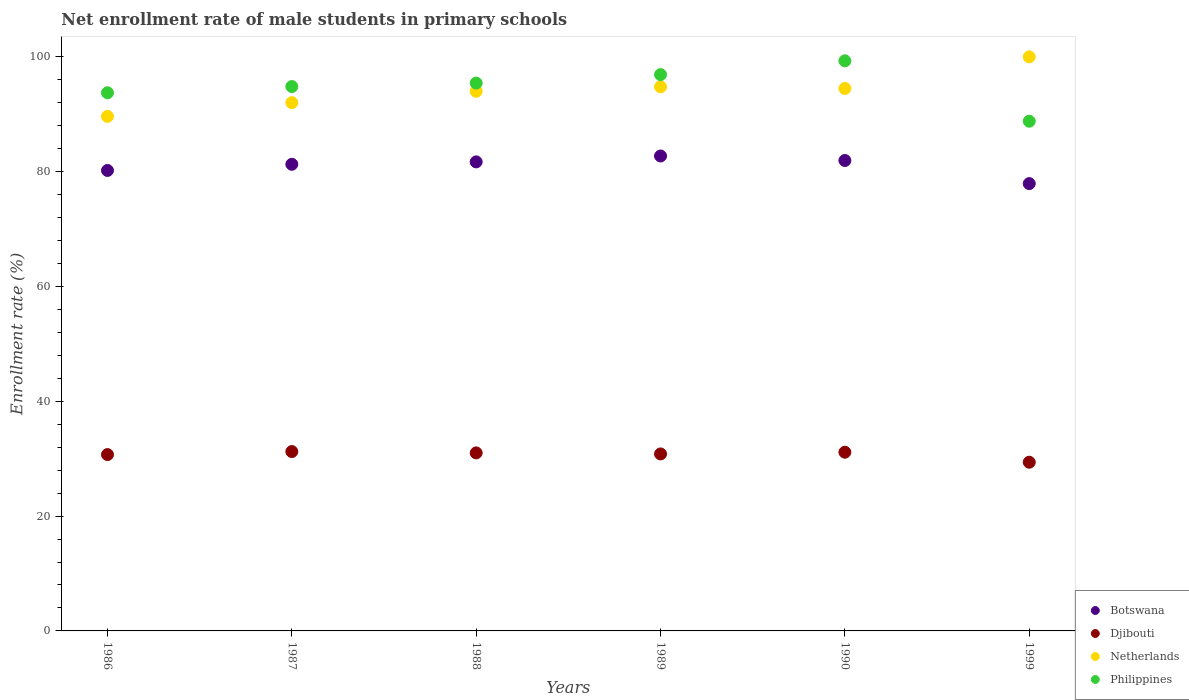What is the net enrollment rate of male students in primary schools in Djibouti in 1986?
Keep it short and to the point. 30.71. Across all years, what is the maximum net enrollment rate of male students in primary schools in Djibouti?
Offer a very short reply. 31.24. Across all years, what is the minimum net enrollment rate of male students in primary schools in Djibouti?
Your answer should be compact. 29.38. What is the total net enrollment rate of male students in primary schools in Philippines in the graph?
Ensure brevity in your answer.  568.92. What is the difference between the net enrollment rate of male students in primary schools in Netherlands in 1986 and that in 1988?
Provide a succinct answer. -4.37. What is the difference between the net enrollment rate of male students in primary schools in Djibouti in 1989 and the net enrollment rate of male students in primary schools in Netherlands in 1986?
Provide a short and direct response. -58.79. What is the average net enrollment rate of male students in primary schools in Netherlands per year?
Give a very brief answer. 94.14. In the year 1986, what is the difference between the net enrollment rate of male students in primary schools in Philippines and net enrollment rate of male students in primary schools in Botswana?
Offer a terse response. 13.53. What is the ratio of the net enrollment rate of male students in primary schools in Philippines in 1986 to that in 1989?
Give a very brief answer. 0.97. Is the difference between the net enrollment rate of male students in primary schools in Philippines in 1988 and 1989 greater than the difference between the net enrollment rate of male students in primary schools in Botswana in 1988 and 1989?
Provide a succinct answer. No. What is the difference between the highest and the second highest net enrollment rate of male students in primary schools in Botswana?
Make the answer very short. 0.79. What is the difference between the highest and the lowest net enrollment rate of male students in primary schools in Djibouti?
Your response must be concise. 1.86. Is the sum of the net enrollment rate of male students in primary schools in Djibouti in 1988 and 1989 greater than the maximum net enrollment rate of male students in primary schools in Botswana across all years?
Ensure brevity in your answer.  No. Is it the case that in every year, the sum of the net enrollment rate of male students in primary schools in Philippines and net enrollment rate of male students in primary schools in Botswana  is greater than the sum of net enrollment rate of male students in primary schools in Netherlands and net enrollment rate of male students in primary schools in Djibouti?
Make the answer very short. Yes. Is the net enrollment rate of male students in primary schools in Djibouti strictly greater than the net enrollment rate of male students in primary schools in Netherlands over the years?
Offer a very short reply. No. How many dotlines are there?
Keep it short and to the point. 4. Are the values on the major ticks of Y-axis written in scientific E-notation?
Provide a succinct answer. No. What is the title of the graph?
Give a very brief answer. Net enrollment rate of male students in primary schools. Does "Guam" appear as one of the legend labels in the graph?
Offer a very short reply. No. What is the label or title of the Y-axis?
Keep it short and to the point. Enrollment rate (%). What is the Enrollment rate (%) of Botswana in 1986?
Your response must be concise. 80.2. What is the Enrollment rate (%) of Djibouti in 1986?
Keep it short and to the point. 30.71. What is the Enrollment rate (%) in Netherlands in 1986?
Offer a terse response. 89.61. What is the Enrollment rate (%) in Philippines in 1986?
Your answer should be very brief. 93.73. What is the Enrollment rate (%) in Botswana in 1987?
Your answer should be very brief. 81.27. What is the Enrollment rate (%) of Djibouti in 1987?
Make the answer very short. 31.24. What is the Enrollment rate (%) in Netherlands in 1987?
Give a very brief answer. 92. What is the Enrollment rate (%) of Philippines in 1987?
Provide a short and direct response. 94.81. What is the Enrollment rate (%) in Botswana in 1988?
Offer a very short reply. 81.69. What is the Enrollment rate (%) of Djibouti in 1988?
Offer a very short reply. 31.01. What is the Enrollment rate (%) in Netherlands in 1988?
Your answer should be compact. 93.98. What is the Enrollment rate (%) of Philippines in 1988?
Make the answer very short. 95.42. What is the Enrollment rate (%) in Botswana in 1989?
Offer a very short reply. 82.72. What is the Enrollment rate (%) of Djibouti in 1989?
Make the answer very short. 30.83. What is the Enrollment rate (%) in Netherlands in 1989?
Your response must be concise. 94.76. What is the Enrollment rate (%) in Philippines in 1989?
Offer a very short reply. 96.89. What is the Enrollment rate (%) in Botswana in 1990?
Your answer should be compact. 81.93. What is the Enrollment rate (%) of Djibouti in 1990?
Provide a succinct answer. 31.12. What is the Enrollment rate (%) of Netherlands in 1990?
Your response must be concise. 94.48. What is the Enrollment rate (%) of Philippines in 1990?
Give a very brief answer. 99.29. What is the Enrollment rate (%) of Botswana in 1999?
Keep it short and to the point. 77.91. What is the Enrollment rate (%) in Djibouti in 1999?
Offer a terse response. 29.38. What is the Enrollment rate (%) of Netherlands in 1999?
Give a very brief answer. 99.99. What is the Enrollment rate (%) in Philippines in 1999?
Offer a terse response. 88.77. Across all years, what is the maximum Enrollment rate (%) of Botswana?
Provide a succinct answer. 82.72. Across all years, what is the maximum Enrollment rate (%) of Djibouti?
Your answer should be compact. 31.24. Across all years, what is the maximum Enrollment rate (%) of Netherlands?
Provide a short and direct response. 99.99. Across all years, what is the maximum Enrollment rate (%) in Philippines?
Keep it short and to the point. 99.29. Across all years, what is the minimum Enrollment rate (%) in Botswana?
Your answer should be very brief. 77.91. Across all years, what is the minimum Enrollment rate (%) in Djibouti?
Keep it short and to the point. 29.38. Across all years, what is the minimum Enrollment rate (%) of Netherlands?
Your response must be concise. 89.61. Across all years, what is the minimum Enrollment rate (%) in Philippines?
Make the answer very short. 88.77. What is the total Enrollment rate (%) in Botswana in the graph?
Keep it short and to the point. 485.72. What is the total Enrollment rate (%) of Djibouti in the graph?
Your answer should be very brief. 184.29. What is the total Enrollment rate (%) in Netherlands in the graph?
Ensure brevity in your answer.  564.83. What is the total Enrollment rate (%) of Philippines in the graph?
Your answer should be compact. 568.92. What is the difference between the Enrollment rate (%) of Botswana in 1986 and that in 1987?
Give a very brief answer. -1.08. What is the difference between the Enrollment rate (%) of Djibouti in 1986 and that in 1987?
Your response must be concise. -0.53. What is the difference between the Enrollment rate (%) in Netherlands in 1986 and that in 1987?
Offer a very short reply. -2.39. What is the difference between the Enrollment rate (%) of Philippines in 1986 and that in 1987?
Provide a short and direct response. -1.08. What is the difference between the Enrollment rate (%) of Botswana in 1986 and that in 1988?
Provide a short and direct response. -1.49. What is the difference between the Enrollment rate (%) of Djibouti in 1986 and that in 1988?
Provide a succinct answer. -0.29. What is the difference between the Enrollment rate (%) of Netherlands in 1986 and that in 1988?
Offer a terse response. -4.37. What is the difference between the Enrollment rate (%) of Philippines in 1986 and that in 1988?
Provide a short and direct response. -1.69. What is the difference between the Enrollment rate (%) of Botswana in 1986 and that in 1989?
Ensure brevity in your answer.  -2.52. What is the difference between the Enrollment rate (%) in Djibouti in 1986 and that in 1989?
Give a very brief answer. -0.11. What is the difference between the Enrollment rate (%) of Netherlands in 1986 and that in 1989?
Make the answer very short. -5.15. What is the difference between the Enrollment rate (%) in Philippines in 1986 and that in 1989?
Make the answer very short. -3.16. What is the difference between the Enrollment rate (%) in Botswana in 1986 and that in 1990?
Provide a short and direct response. -1.73. What is the difference between the Enrollment rate (%) in Djibouti in 1986 and that in 1990?
Keep it short and to the point. -0.41. What is the difference between the Enrollment rate (%) in Netherlands in 1986 and that in 1990?
Keep it short and to the point. -4.87. What is the difference between the Enrollment rate (%) in Philippines in 1986 and that in 1990?
Your answer should be compact. -5.56. What is the difference between the Enrollment rate (%) of Botswana in 1986 and that in 1999?
Offer a terse response. 2.29. What is the difference between the Enrollment rate (%) of Djibouti in 1986 and that in 1999?
Offer a terse response. 1.33. What is the difference between the Enrollment rate (%) in Netherlands in 1986 and that in 1999?
Give a very brief answer. -10.37. What is the difference between the Enrollment rate (%) of Philippines in 1986 and that in 1999?
Make the answer very short. 4.96. What is the difference between the Enrollment rate (%) of Botswana in 1987 and that in 1988?
Ensure brevity in your answer.  -0.42. What is the difference between the Enrollment rate (%) of Djibouti in 1987 and that in 1988?
Your answer should be compact. 0.23. What is the difference between the Enrollment rate (%) in Netherlands in 1987 and that in 1988?
Give a very brief answer. -1.98. What is the difference between the Enrollment rate (%) in Philippines in 1987 and that in 1988?
Keep it short and to the point. -0.6. What is the difference between the Enrollment rate (%) in Botswana in 1987 and that in 1989?
Offer a very short reply. -1.44. What is the difference between the Enrollment rate (%) of Djibouti in 1987 and that in 1989?
Provide a short and direct response. 0.41. What is the difference between the Enrollment rate (%) in Netherlands in 1987 and that in 1989?
Give a very brief answer. -2.76. What is the difference between the Enrollment rate (%) in Philippines in 1987 and that in 1989?
Offer a terse response. -2.08. What is the difference between the Enrollment rate (%) of Botswana in 1987 and that in 1990?
Provide a short and direct response. -0.66. What is the difference between the Enrollment rate (%) in Djibouti in 1987 and that in 1990?
Give a very brief answer. 0.11. What is the difference between the Enrollment rate (%) in Netherlands in 1987 and that in 1990?
Your answer should be very brief. -2.48. What is the difference between the Enrollment rate (%) of Philippines in 1987 and that in 1990?
Provide a short and direct response. -4.48. What is the difference between the Enrollment rate (%) of Botswana in 1987 and that in 1999?
Your answer should be very brief. 3.36. What is the difference between the Enrollment rate (%) of Djibouti in 1987 and that in 1999?
Give a very brief answer. 1.86. What is the difference between the Enrollment rate (%) of Netherlands in 1987 and that in 1999?
Offer a very short reply. -7.98. What is the difference between the Enrollment rate (%) of Philippines in 1987 and that in 1999?
Keep it short and to the point. 6.04. What is the difference between the Enrollment rate (%) in Botswana in 1988 and that in 1989?
Your answer should be very brief. -1.03. What is the difference between the Enrollment rate (%) of Djibouti in 1988 and that in 1989?
Make the answer very short. 0.18. What is the difference between the Enrollment rate (%) of Netherlands in 1988 and that in 1989?
Offer a very short reply. -0.78. What is the difference between the Enrollment rate (%) of Philippines in 1988 and that in 1989?
Provide a succinct answer. -1.47. What is the difference between the Enrollment rate (%) of Botswana in 1988 and that in 1990?
Give a very brief answer. -0.24. What is the difference between the Enrollment rate (%) of Djibouti in 1988 and that in 1990?
Offer a very short reply. -0.12. What is the difference between the Enrollment rate (%) in Netherlands in 1988 and that in 1990?
Give a very brief answer. -0.5. What is the difference between the Enrollment rate (%) of Philippines in 1988 and that in 1990?
Provide a short and direct response. -3.88. What is the difference between the Enrollment rate (%) in Botswana in 1988 and that in 1999?
Your response must be concise. 3.78. What is the difference between the Enrollment rate (%) of Djibouti in 1988 and that in 1999?
Your answer should be compact. 1.62. What is the difference between the Enrollment rate (%) in Netherlands in 1988 and that in 1999?
Provide a succinct answer. -6. What is the difference between the Enrollment rate (%) in Philippines in 1988 and that in 1999?
Your response must be concise. 6.64. What is the difference between the Enrollment rate (%) of Botswana in 1989 and that in 1990?
Provide a short and direct response. 0.79. What is the difference between the Enrollment rate (%) of Djibouti in 1989 and that in 1990?
Keep it short and to the point. -0.3. What is the difference between the Enrollment rate (%) of Netherlands in 1989 and that in 1990?
Offer a terse response. 0.28. What is the difference between the Enrollment rate (%) of Philippines in 1989 and that in 1990?
Give a very brief answer. -2.4. What is the difference between the Enrollment rate (%) in Botswana in 1989 and that in 1999?
Your answer should be very brief. 4.81. What is the difference between the Enrollment rate (%) in Djibouti in 1989 and that in 1999?
Offer a terse response. 1.44. What is the difference between the Enrollment rate (%) in Netherlands in 1989 and that in 1999?
Offer a terse response. -5.22. What is the difference between the Enrollment rate (%) in Philippines in 1989 and that in 1999?
Your response must be concise. 8.12. What is the difference between the Enrollment rate (%) of Botswana in 1990 and that in 1999?
Offer a very short reply. 4.02. What is the difference between the Enrollment rate (%) in Djibouti in 1990 and that in 1999?
Your response must be concise. 1.74. What is the difference between the Enrollment rate (%) of Netherlands in 1990 and that in 1999?
Offer a terse response. -5.51. What is the difference between the Enrollment rate (%) of Philippines in 1990 and that in 1999?
Ensure brevity in your answer.  10.52. What is the difference between the Enrollment rate (%) in Botswana in 1986 and the Enrollment rate (%) in Djibouti in 1987?
Offer a very short reply. 48.96. What is the difference between the Enrollment rate (%) of Botswana in 1986 and the Enrollment rate (%) of Netherlands in 1987?
Make the answer very short. -11.81. What is the difference between the Enrollment rate (%) in Botswana in 1986 and the Enrollment rate (%) in Philippines in 1987?
Offer a very short reply. -14.62. What is the difference between the Enrollment rate (%) of Djibouti in 1986 and the Enrollment rate (%) of Netherlands in 1987?
Your response must be concise. -61.29. What is the difference between the Enrollment rate (%) in Djibouti in 1986 and the Enrollment rate (%) in Philippines in 1987?
Provide a short and direct response. -64.1. What is the difference between the Enrollment rate (%) in Netherlands in 1986 and the Enrollment rate (%) in Philippines in 1987?
Your answer should be compact. -5.2. What is the difference between the Enrollment rate (%) of Botswana in 1986 and the Enrollment rate (%) of Djibouti in 1988?
Your response must be concise. 49.19. What is the difference between the Enrollment rate (%) of Botswana in 1986 and the Enrollment rate (%) of Netherlands in 1988?
Your answer should be compact. -13.79. What is the difference between the Enrollment rate (%) in Botswana in 1986 and the Enrollment rate (%) in Philippines in 1988?
Your answer should be compact. -15.22. What is the difference between the Enrollment rate (%) in Djibouti in 1986 and the Enrollment rate (%) in Netherlands in 1988?
Keep it short and to the point. -63.27. What is the difference between the Enrollment rate (%) in Djibouti in 1986 and the Enrollment rate (%) in Philippines in 1988?
Keep it short and to the point. -64.71. What is the difference between the Enrollment rate (%) of Netherlands in 1986 and the Enrollment rate (%) of Philippines in 1988?
Ensure brevity in your answer.  -5.8. What is the difference between the Enrollment rate (%) in Botswana in 1986 and the Enrollment rate (%) in Djibouti in 1989?
Offer a very short reply. 49.37. What is the difference between the Enrollment rate (%) of Botswana in 1986 and the Enrollment rate (%) of Netherlands in 1989?
Offer a very short reply. -14.56. What is the difference between the Enrollment rate (%) of Botswana in 1986 and the Enrollment rate (%) of Philippines in 1989?
Give a very brief answer. -16.69. What is the difference between the Enrollment rate (%) in Djibouti in 1986 and the Enrollment rate (%) in Netherlands in 1989?
Provide a short and direct response. -64.05. What is the difference between the Enrollment rate (%) of Djibouti in 1986 and the Enrollment rate (%) of Philippines in 1989?
Keep it short and to the point. -66.18. What is the difference between the Enrollment rate (%) in Netherlands in 1986 and the Enrollment rate (%) in Philippines in 1989?
Make the answer very short. -7.28. What is the difference between the Enrollment rate (%) of Botswana in 1986 and the Enrollment rate (%) of Djibouti in 1990?
Give a very brief answer. 49.07. What is the difference between the Enrollment rate (%) in Botswana in 1986 and the Enrollment rate (%) in Netherlands in 1990?
Make the answer very short. -14.28. What is the difference between the Enrollment rate (%) in Botswana in 1986 and the Enrollment rate (%) in Philippines in 1990?
Make the answer very short. -19.1. What is the difference between the Enrollment rate (%) of Djibouti in 1986 and the Enrollment rate (%) of Netherlands in 1990?
Provide a succinct answer. -63.77. What is the difference between the Enrollment rate (%) of Djibouti in 1986 and the Enrollment rate (%) of Philippines in 1990?
Your response must be concise. -68.58. What is the difference between the Enrollment rate (%) in Netherlands in 1986 and the Enrollment rate (%) in Philippines in 1990?
Ensure brevity in your answer.  -9.68. What is the difference between the Enrollment rate (%) in Botswana in 1986 and the Enrollment rate (%) in Djibouti in 1999?
Give a very brief answer. 50.81. What is the difference between the Enrollment rate (%) of Botswana in 1986 and the Enrollment rate (%) of Netherlands in 1999?
Ensure brevity in your answer.  -19.79. What is the difference between the Enrollment rate (%) in Botswana in 1986 and the Enrollment rate (%) in Philippines in 1999?
Offer a terse response. -8.58. What is the difference between the Enrollment rate (%) in Djibouti in 1986 and the Enrollment rate (%) in Netherlands in 1999?
Keep it short and to the point. -69.27. What is the difference between the Enrollment rate (%) in Djibouti in 1986 and the Enrollment rate (%) in Philippines in 1999?
Your answer should be compact. -58.06. What is the difference between the Enrollment rate (%) of Netherlands in 1986 and the Enrollment rate (%) of Philippines in 1999?
Offer a terse response. 0.84. What is the difference between the Enrollment rate (%) in Botswana in 1987 and the Enrollment rate (%) in Djibouti in 1988?
Give a very brief answer. 50.27. What is the difference between the Enrollment rate (%) in Botswana in 1987 and the Enrollment rate (%) in Netherlands in 1988?
Ensure brevity in your answer.  -12.71. What is the difference between the Enrollment rate (%) in Botswana in 1987 and the Enrollment rate (%) in Philippines in 1988?
Your response must be concise. -14.15. What is the difference between the Enrollment rate (%) of Djibouti in 1987 and the Enrollment rate (%) of Netherlands in 1988?
Your response must be concise. -62.75. What is the difference between the Enrollment rate (%) of Djibouti in 1987 and the Enrollment rate (%) of Philippines in 1988?
Your response must be concise. -64.18. What is the difference between the Enrollment rate (%) of Netherlands in 1987 and the Enrollment rate (%) of Philippines in 1988?
Offer a very short reply. -3.41. What is the difference between the Enrollment rate (%) of Botswana in 1987 and the Enrollment rate (%) of Djibouti in 1989?
Keep it short and to the point. 50.45. What is the difference between the Enrollment rate (%) of Botswana in 1987 and the Enrollment rate (%) of Netherlands in 1989?
Give a very brief answer. -13.49. What is the difference between the Enrollment rate (%) of Botswana in 1987 and the Enrollment rate (%) of Philippines in 1989?
Give a very brief answer. -15.62. What is the difference between the Enrollment rate (%) in Djibouti in 1987 and the Enrollment rate (%) in Netherlands in 1989?
Make the answer very short. -63.52. What is the difference between the Enrollment rate (%) of Djibouti in 1987 and the Enrollment rate (%) of Philippines in 1989?
Offer a very short reply. -65.65. What is the difference between the Enrollment rate (%) of Netherlands in 1987 and the Enrollment rate (%) of Philippines in 1989?
Make the answer very short. -4.89. What is the difference between the Enrollment rate (%) in Botswana in 1987 and the Enrollment rate (%) in Djibouti in 1990?
Your answer should be very brief. 50.15. What is the difference between the Enrollment rate (%) of Botswana in 1987 and the Enrollment rate (%) of Netherlands in 1990?
Your response must be concise. -13.21. What is the difference between the Enrollment rate (%) of Botswana in 1987 and the Enrollment rate (%) of Philippines in 1990?
Keep it short and to the point. -18.02. What is the difference between the Enrollment rate (%) in Djibouti in 1987 and the Enrollment rate (%) in Netherlands in 1990?
Your response must be concise. -63.24. What is the difference between the Enrollment rate (%) of Djibouti in 1987 and the Enrollment rate (%) of Philippines in 1990?
Your answer should be compact. -68.05. What is the difference between the Enrollment rate (%) of Netherlands in 1987 and the Enrollment rate (%) of Philippines in 1990?
Make the answer very short. -7.29. What is the difference between the Enrollment rate (%) of Botswana in 1987 and the Enrollment rate (%) of Djibouti in 1999?
Offer a very short reply. 51.89. What is the difference between the Enrollment rate (%) in Botswana in 1987 and the Enrollment rate (%) in Netherlands in 1999?
Provide a succinct answer. -18.71. What is the difference between the Enrollment rate (%) of Botswana in 1987 and the Enrollment rate (%) of Philippines in 1999?
Ensure brevity in your answer.  -7.5. What is the difference between the Enrollment rate (%) in Djibouti in 1987 and the Enrollment rate (%) in Netherlands in 1999?
Your response must be concise. -68.75. What is the difference between the Enrollment rate (%) of Djibouti in 1987 and the Enrollment rate (%) of Philippines in 1999?
Your response must be concise. -57.53. What is the difference between the Enrollment rate (%) in Netherlands in 1987 and the Enrollment rate (%) in Philippines in 1999?
Provide a short and direct response. 3.23. What is the difference between the Enrollment rate (%) of Botswana in 1988 and the Enrollment rate (%) of Djibouti in 1989?
Your answer should be compact. 50.87. What is the difference between the Enrollment rate (%) of Botswana in 1988 and the Enrollment rate (%) of Netherlands in 1989?
Keep it short and to the point. -13.07. What is the difference between the Enrollment rate (%) of Botswana in 1988 and the Enrollment rate (%) of Philippines in 1989?
Provide a short and direct response. -15.2. What is the difference between the Enrollment rate (%) of Djibouti in 1988 and the Enrollment rate (%) of Netherlands in 1989?
Offer a terse response. -63.75. What is the difference between the Enrollment rate (%) of Djibouti in 1988 and the Enrollment rate (%) of Philippines in 1989?
Keep it short and to the point. -65.88. What is the difference between the Enrollment rate (%) of Netherlands in 1988 and the Enrollment rate (%) of Philippines in 1989?
Make the answer very short. -2.91. What is the difference between the Enrollment rate (%) in Botswana in 1988 and the Enrollment rate (%) in Djibouti in 1990?
Your answer should be compact. 50.57. What is the difference between the Enrollment rate (%) of Botswana in 1988 and the Enrollment rate (%) of Netherlands in 1990?
Ensure brevity in your answer.  -12.79. What is the difference between the Enrollment rate (%) of Botswana in 1988 and the Enrollment rate (%) of Philippines in 1990?
Ensure brevity in your answer.  -17.6. What is the difference between the Enrollment rate (%) of Djibouti in 1988 and the Enrollment rate (%) of Netherlands in 1990?
Offer a terse response. -63.47. What is the difference between the Enrollment rate (%) of Djibouti in 1988 and the Enrollment rate (%) of Philippines in 1990?
Provide a succinct answer. -68.29. What is the difference between the Enrollment rate (%) in Netherlands in 1988 and the Enrollment rate (%) in Philippines in 1990?
Offer a terse response. -5.31. What is the difference between the Enrollment rate (%) in Botswana in 1988 and the Enrollment rate (%) in Djibouti in 1999?
Make the answer very short. 52.31. What is the difference between the Enrollment rate (%) in Botswana in 1988 and the Enrollment rate (%) in Netherlands in 1999?
Provide a short and direct response. -18.29. What is the difference between the Enrollment rate (%) of Botswana in 1988 and the Enrollment rate (%) of Philippines in 1999?
Give a very brief answer. -7.08. What is the difference between the Enrollment rate (%) of Djibouti in 1988 and the Enrollment rate (%) of Netherlands in 1999?
Your response must be concise. -68.98. What is the difference between the Enrollment rate (%) in Djibouti in 1988 and the Enrollment rate (%) in Philippines in 1999?
Provide a short and direct response. -57.77. What is the difference between the Enrollment rate (%) of Netherlands in 1988 and the Enrollment rate (%) of Philippines in 1999?
Give a very brief answer. 5.21. What is the difference between the Enrollment rate (%) of Botswana in 1989 and the Enrollment rate (%) of Djibouti in 1990?
Keep it short and to the point. 51.59. What is the difference between the Enrollment rate (%) in Botswana in 1989 and the Enrollment rate (%) in Netherlands in 1990?
Make the answer very short. -11.76. What is the difference between the Enrollment rate (%) of Botswana in 1989 and the Enrollment rate (%) of Philippines in 1990?
Offer a terse response. -16.58. What is the difference between the Enrollment rate (%) of Djibouti in 1989 and the Enrollment rate (%) of Netherlands in 1990?
Ensure brevity in your answer.  -63.66. What is the difference between the Enrollment rate (%) of Djibouti in 1989 and the Enrollment rate (%) of Philippines in 1990?
Keep it short and to the point. -68.47. What is the difference between the Enrollment rate (%) in Netherlands in 1989 and the Enrollment rate (%) in Philippines in 1990?
Offer a very short reply. -4.53. What is the difference between the Enrollment rate (%) of Botswana in 1989 and the Enrollment rate (%) of Djibouti in 1999?
Your response must be concise. 53.33. What is the difference between the Enrollment rate (%) in Botswana in 1989 and the Enrollment rate (%) in Netherlands in 1999?
Offer a very short reply. -17.27. What is the difference between the Enrollment rate (%) in Botswana in 1989 and the Enrollment rate (%) in Philippines in 1999?
Keep it short and to the point. -6.06. What is the difference between the Enrollment rate (%) in Djibouti in 1989 and the Enrollment rate (%) in Netherlands in 1999?
Provide a succinct answer. -69.16. What is the difference between the Enrollment rate (%) in Djibouti in 1989 and the Enrollment rate (%) in Philippines in 1999?
Your answer should be very brief. -57.95. What is the difference between the Enrollment rate (%) in Netherlands in 1989 and the Enrollment rate (%) in Philippines in 1999?
Make the answer very short. 5.99. What is the difference between the Enrollment rate (%) of Botswana in 1990 and the Enrollment rate (%) of Djibouti in 1999?
Keep it short and to the point. 52.55. What is the difference between the Enrollment rate (%) in Botswana in 1990 and the Enrollment rate (%) in Netherlands in 1999?
Make the answer very short. -18.05. What is the difference between the Enrollment rate (%) in Botswana in 1990 and the Enrollment rate (%) in Philippines in 1999?
Make the answer very short. -6.84. What is the difference between the Enrollment rate (%) of Djibouti in 1990 and the Enrollment rate (%) of Netherlands in 1999?
Your answer should be very brief. -68.86. What is the difference between the Enrollment rate (%) of Djibouti in 1990 and the Enrollment rate (%) of Philippines in 1999?
Provide a short and direct response. -57.65. What is the difference between the Enrollment rate (%) in Netherlands in 1990 and the Enrollment rate (%) in Philippines in 1999?
Give a very brief answer. 5.71. What is the average Enrollment rate (%) of Botswana per year?
Your answer should be compact. 80.95. What is the average Enrollment rate (%) of Djibouti per year?
Your answer should be very brief. 30.71. What is the average Enrollment rate (%) of Netherlands per year?
Ensure brevity in your answer.  94.14. What is the average Enrollment rate (%) of Philippines per year?
Your answer should be compact. 94.82. In the year 1986, what is the difference between the Enrollment rate (%) of Botswana and Enrollment rate (%) of Djibouti?
Offer a very short reply. 49.48. In the year 1986, what is the difference between the Enrollment rate (%) in Botswana and Enrollment rate (%) in Netherlands?
Your answer should be compact. -9.42. In the year 1986, what is the difference between the Enrollment rate (%) in Botswana and Enrollment rate (%) in Philippines?
Your answer should be very brief. -13.53. In the year 1986, what is the difference between the Enrollment rate (%) of Djibouti and Enrollment rate (%) of Netherlands?
Provide a succinct answer. -58.9. In the year 1986, what is the difference between the Enrollment rate (%) in Djibouti and Enrollment rate (%) in Philippines?
Keep it short and to the point. -63.02. In the year 1986, what is the difference between the Enrollment rate (%) in Netherlands and Enrollment rate (%) in Philippines?
Your response must be concise. -4.12. In the year 1987, what is the difference between the Enrollment rate (%) of Botswana and Enrollment rate (%) of Djibouti?
Give a very brief answer. 50.03. In the year 1987, what is the difference between the Enrollment rate (%) of Botswana and Enrollment rate (%) of Netherlands?
Provide a succinct answer. -10.73. In the year 1987, what is the difference between the Enrollment rate (%) in Botswana and Enrollment rate (%) in Philippines?
Make the answer very short. -13.54. In the year 1987, what is the difference between the Enrollment rate (%) in Djibouti and Enrollment rate (%) in Netherlands?
Give a very brief answer. -60.77. In the year 1987, what is the difference between the Enrollment rate (%) in Djibouti and Enrollment rate (%) in Philippines?
Keep it short and to the point. -63.57. In the year 1987, what is the difference between the Enrollment rate (%) of Netherlands and Enrollment rate (%) of Philippines?
Your response must be concise. -2.81. In the year 1988, what is the difference between the Enrollment rate (%) in Botswana and Enrollment rate (%) in Djibouti?
Offer a terse response. 50.68. In the year 1988, what is the difference between the Enrollment rate (%) in Botswana and Enrollment rate (%) in Netherlands?
Your response must be concise. -12.29. In the year 1988, what is the difference between the Enrollment rate (%) in Botswana and Enrollment rate (%) in Philippines?
Ensure brevity in your answer.  -13.73. In the year 1988, what is the difference between the Enrollment rate (%) in Djibouti and Enrollment rate (%) in Netherlands?
Your answer should be compact. -62.98. In the year 1988, what is the difference between the Enrollment rate (%) in Djibouti and Enrollment rate (%) in Philippines?
Your answer should be compact. -64.41. In the year 1988, what is the difference between the Enrollment rate (%) of Netherlands and Enrollment rate (%) of Philippines?
Give a very brief answer. -1.43. In the year 1989, what is the difference between the Enrollment rate (%) of Botswana and Enrollment rate (%) of Djibouti?
Your answer should be very brief. 51.89. In the year 1989, what is the difference between the Enrollment rate (%) of Botswana and Enrollment rate (%) of Netherlands?
Offer a terse response. -12.04. In the year 1989, what is the difference between the Enrollment rate (%) in Botswana and Enrollment rate (%) in Philippines?
Your response must be concise. -14.17. In the year 1989, what is the difference between the Enrollment rate (%) in Djibouti and Enrollment rate (%) in Netherlands?
Give a very brief answer. -63.94. In the year 1989, what is the difference between the Enrollment rate (%) in Djibouti and Enrollment rate (%) in Philippines?
Offer a very short reply. -66.07. In the year 1989, what is the difference between the Enrollment rate (%) of Netherlands and Enrollment rate (%) of Philippines?
Your answer should be compact. -2.13. In the year 1990, what is the difference between the Enrollment rate (%) of Botswana and Enrollment rate (%) of Djibouti?
Give a very brief answer. 50.81. In the year 1990, what is the difference between the Enrollment rate (%) in Botswana and Enrollment rate (%) in Netherlands?
Provide a succinct answer. -12.55. In the year 1990, what is the difference between the Enrollment rate (%) in Botswana and Enrollment rate (%) in Philippines?
Ensure brevity in your answer.  -17.36. In the year 1990, what is the difference between the Enrollment rate (%) in Djibouti and Enrollment rate (%) in Netherlands?
Your answer should be compact. -63.36. In the year 1990, what is the difference between the Enrollment rate (%) in Djibouti and Enrollment rate (%) in Philippines?
Your answer should be compact. -68.17. In the year 1990, what is the difference between the Enrollment rate (%) in Netherlands and Enrollment rate (%) in Philippines?
Offer a very short reply. -4.81. In the year 1999, what is the difference between the Enrollment rate (%) of Botswana and Enrollment rate (%) of Djibouti?
Keep it short and to the point. 48.53. In the year 1999, what is the difference between the Enrollment rate (%) of Botswana and Enrollment rate (%) of Netherlands?
Your response must be concise. -22.08. In the year 1999, what is the difference between the Enrollment rate (%) of Botswana and Enrollment rate (%) of Philippines?
Offer a terse response. -10.87. In the year 1999, what is the difference between the Enrollment rate (%) in Djibouti and Enrollment rate (%) in Netherlands?
Provide a short and direct response. -70.6. In the year 1999, what is the difference between the Enrollment rate (%) of Djibouti and Enrollment rate (%) of Philippines?
Your answer should be very brief. -59.39. In the year 1999, what is the difference between the Enrollment rate (%) of Netherlands and Enrollment rate (%) of Philippines?
Keep it short and to the point. 11.21. What is the ratio of the Enrollment rate (%) in Djibouti in 1986 to that in 1987?
Keep it short and to the point. 0.98. What is the ratio of the Enrollment rate (%) of Netherlands in 1986 to that in 1987?
Give a very brief answer. 0.97. What is the ratio of the Enrollment rate (%) in Philippines in 1986 to that in 1987?
Your response must be concise. 0.99. What is the ratio of the Enrollment rate (%) in Botswana in 1986 to that in 1988?
Ensure brevity in your answer.  0.98. What is the ratio of the Enrollment rate (%) in Djibouti in 1986 to that in 1988?
Provide a short and direct response. 0.99. What is the ratio of the Enrollment rate (%) of Netherlands in 1986 to that in 1988?
Offer a very short reply. 0.95. What is the ratio of the Enrollment rate (%) in Philippines in 1986 to that in 1988?
Ensure brevity in your answer.  0.98. What is the ratio of the Enrollment rate (%) in Botswana in 1986 to that in 1989?
Ensure brevity in your answer.  0.97. What is the ratio of the Enrollment rate (%) of Djibouti in 1986 to that in 1989?
Offer a terse response. 1. What is the ratio of the Enrollment rate (%) of Netherlands in 1986 to that in 1989?
Your answer should be very brief. 0.95. What is the ratio of the Enrollment rate (%) in Philippines in 1986 to that in 1989?
Your answer should be compact. 0.97. What is the ratio of the Enrollment rate (%) of Botswana in 1986 to that in 1990?
Provide a succinct answer. 0.98. What is the ratio of the Enrollment rate (%) in Djibouti in 1986 to that in 1990?
Your answer should be very brief. 0.99. What is the ratio of the Enrollment rate (%) of Netherlands in 1986 to that in 1990?
Your response must be concise. 0.95. What is the ratio of the Enrollment rate (%) of Philippines in 1986 to that in 1990?
Make the answer very short. 0.94. What is the ratio of the Enrollment rate (%) of Botswana in 1986 to that in 1999?
Your answer should be compact. 1.03. What is the ratio of the Enrollment rate (%) in Djibouti in 1986 to that in 1999?
Your answer should be very brief. 1.05. What is the ratio of the Enrollment rate (%) of Netherlands in 1986 to that in 1999?
Offer a terse response. 0.9. What is the ratio of the Enrollment rate (%) in Philippines in 1986 to that in 1999?
Provide a short and direct response. 1.06. What is the ratio of the Enrollment rate (%) of Botswana in 1987 to that in 1988?
Offer a terse response. 0.99. What is the ratio of the Enrollment rate (%) of Djibouti in 1987 to that in 1988?
Your answer should be compact. 1.01. What is the ratio of the Enrollment rate (%) of Netherlands in 1987 to that in 1988?
Make the answer very short. 0.98. What is the ratio of the Enrollment rate (%) of Botswana in 1987 to that in 1989?
Give a very brief answer. 0.98. What is the ratio of the Enrollment rate (%) in Djibouti in 1987 to that in 1989?
Keep it short and to the point. 1.01. What is the ratio of the Enrollment rate (%) in Netherlands in 1987 to that in 1989?
Your answer should be compact. 0.97. What is the ratio of the Enrollment rate (%) of Philippines in 1987 to that in 1989?
Your response must be concise. 0.98. What is the ratio of the Enrollment rate (%) of Botswana in 1987 to that in 1990?
Offer a very short reply. 0.99. What is the ratio of the Enrollment rate (%) of Djibouti in 1987 to that in 1990?
Ensure brevity in your answer.  1. What is the ratio of the Enrollment rate (%) in Netherlands in 1987 to that in 1990?
Your answer should be compact. 0.97. What is the ratio of the Enrollment rate (%) of Philippines in 1987 to that in 1990?
Make the answer very short. 0.95. What is the ratio of the Enrollment rate (%) of Botswana in 1987 to that in 1999?
Your answer should be very brief. 1.04. What is the ratio of the Enrollment rate (%) in Djibouti in 1987 to that in 1999?
Provide a succinct answer. 1.06. What is the ratio of the Enrollment rate (%) of Netherlands in 1987 to that in 1999?
Offer a very short reply. 0.92. What is the ratio of the Enrollment rate (%) of Philippines in 1987 to that in 1999?
Your answer should be very brief. 1.07. What is the ratio of the Enrollment rate (%) of Botswana in 1988 to that in 1989?
Make the answer very short. 0.99. What is the ratio of the Enrollment rate (%) in Djibouti in 1988 to that in 1989?
Provide a succinct answer. 1.01. What is the ratio of the Enrollment rate (%) of Philippines in 1988 to that in 1989?
Provide a short and direct response. 0.98. What is the ratio of the Enrollment rate (%) in Botswana in 1988 to that in 1990?
Provide a succinct answer. 1. What is the ratio of the Enrollment rate (%) in Botswana in 1988 to that in 1999?
Ensure brevity in your answer.  1.05. What is the ratio of the Enrollment rate (%) in Djibouti in 1988 to that in 1999?
Provide a short and direct response. 1.06. What is the ratio of the Enrollment rate (%) in Netherlands in 1988 to that in 1999?
Ensure brevity in your answer.  0.94. What is the ratio of the Enrollment rate (%) of Philippines in 1988 to that in 1999?
Make the answer very short. 1.07. What is the ratio of the Enrollment rate (%) of Botswana in 1989 to that in 1990?
Keep it short and to the point. 1.01. What is the ratio of the Enrollment rate (%) of Djibouti in 1989 to that in 1990?
Give a very brief answer. 0.99. What is the ratio of the Enrollment rate (%) in Philippines in 1989 to that in 1990?
Provide a short and direct response. 0.98. What is the ratio of the Enrollment rate (%) of Botswana in 1989 to that in 1999?
Keep it short and to the point. 1.06. What is the ratio of the Enrollment rate (%) in Djibouti in 1989 to that in 1999?
Make the answer very short. 1.05. What is the ratio of the Enrollment rate (%) in Netherlands in 1989 to that in 1999?
Offer a terse response. 0.95. What is the ratio of the Enrollment rate (%) in Philippines in 1989 to that in 1999?
Ensure brevity in your answer.  1.09. What is the ratio of the Enrollment rate (%) in Botswana in 1990 to that in 1999?
Your answer should be very brief. 1.05. What is the ratio of the Enrollment rate (%) in Djibouti in 1990 to that in 1999?
Give a very brief answer. 1.06. What is the ratio of the Enrollment rate (%) of Netherlands in 1990 to that in 1999?
Your answer should be very brief. 0.94. What is the ratio of the Enrollment rate (%) in Philippines in 1990 to that in 1999?
Provide a short and direct response. 1.12. What is the difference between the highest and the second highest Enrollment rate (%) in Botswana?
Give a very brief answer. 0.79. What is the difference between the highest and the second highest Enrollment rate (%) in Djibouti?
Offer a very short reply. 0.11. What is the difference between the highest and the second highest Enrollment rate (%) in Netherlands?
Offer a very short reply. 5.22. What is the difference between the highest and the second highest Enrollment rate (%) of Philippines?
Ensure brevity in your answer.  2.4. What is the difference between the highest and the lowest Enrollment rate (%) in Botswana?
Make the answer very short. 4.81. What is the difference between the highest and the lowest Enrollment rate (%) of Djibouti?
Provide a succinct answer. 1.86. What is the difference between the highest and the lowest Enrollment rate (%) of Netherlands?
Your answer should be compact. 10.37. What is the difference between the highest and the lowest Enrollment rate (%) in Philippines?
Your answer should be compact. 10.52. 